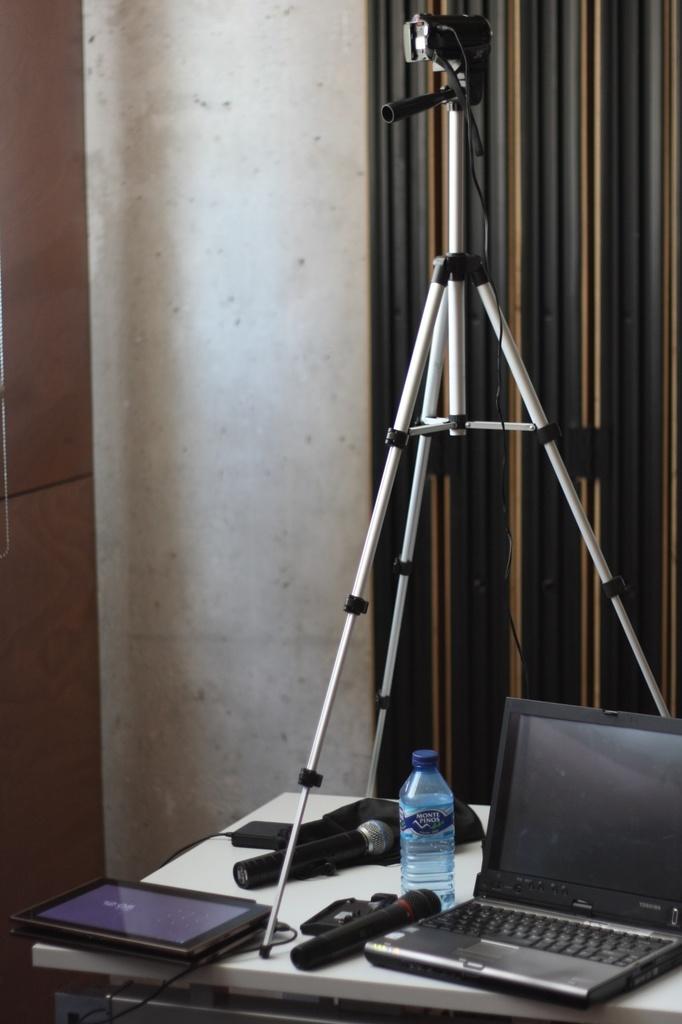Please provide a concise description of this image. This image consists of a camera stand in the middle. it is placed on a table which is in the bottom. On the table there is a mic, iPad, water bottle and laptop. Behind the camera stand there is a curtain. 